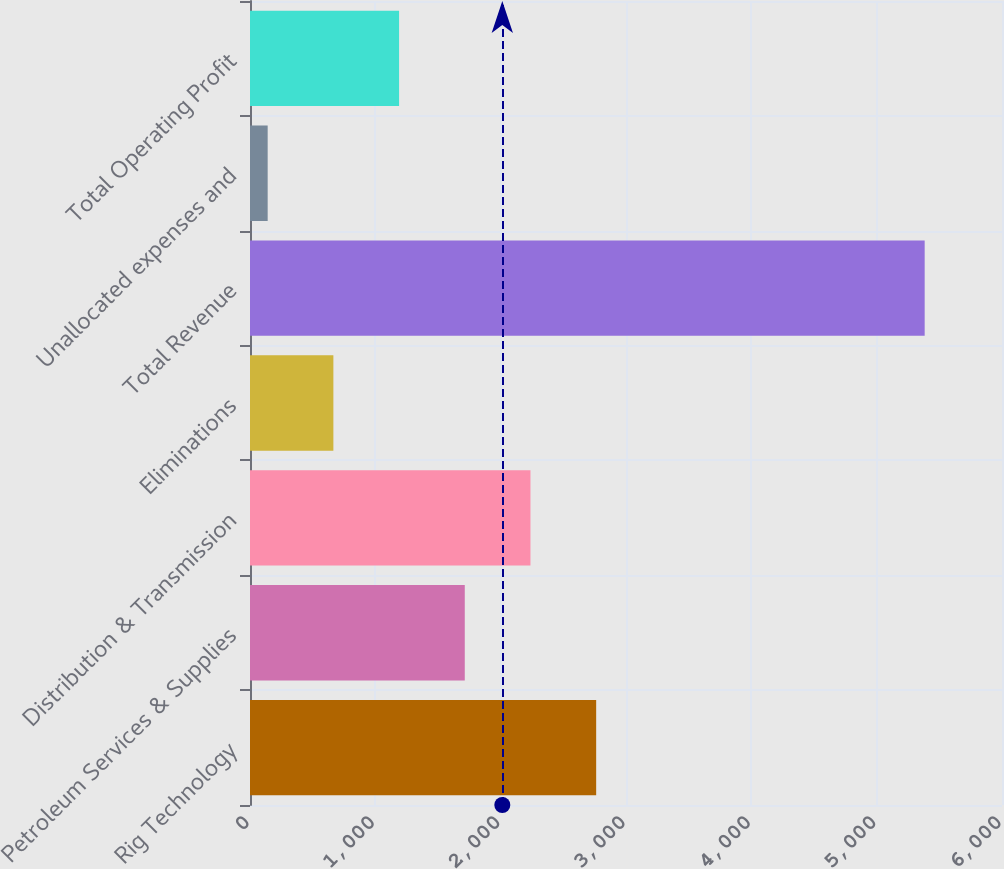Convert chart. <chart><loc_0><loc_0><loc_500><loc_500><bar_chart><fcel>Rig Technology<fcel>Petroleum Services & Supplies<fcel>Distribution & Transmission<fcel>Eliminations<fcel>Total Revenue<fcel>Unallocated expenses and<fcel>Total Operating Profit<nl><fcel>2762<fcel>1713.6<fcel>2237.8<fcel>665.2<fcel>5383<fcel>141<fcel>1189.4<nl></chart> 